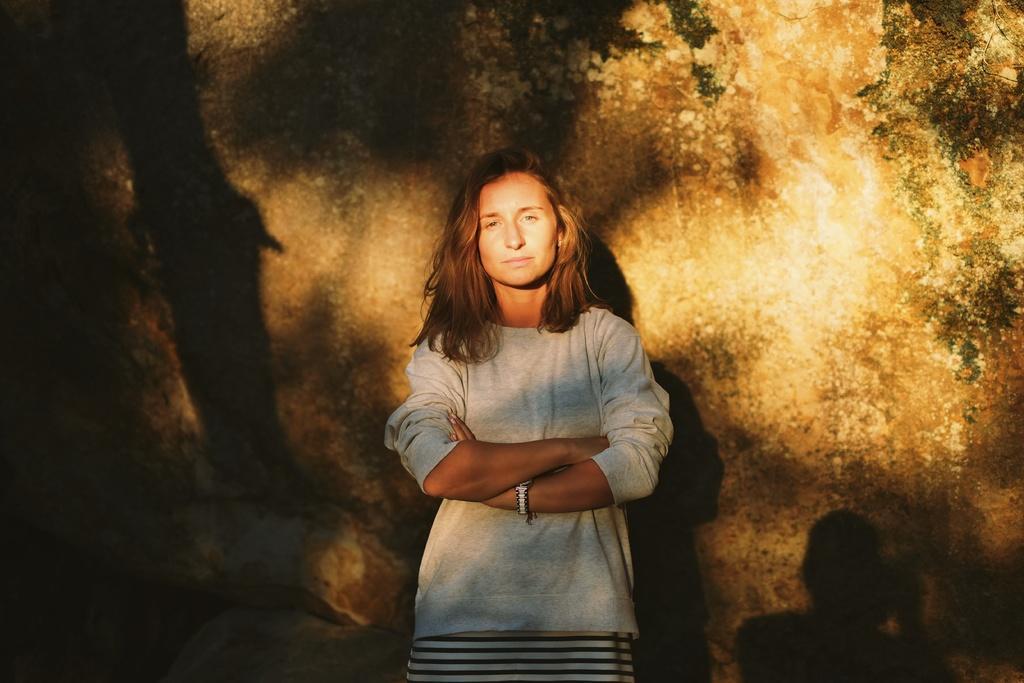In one or two sentences, can you explain what this image depicts? In this picture we can see a woman standing and smiling and in the background we can see wall. 